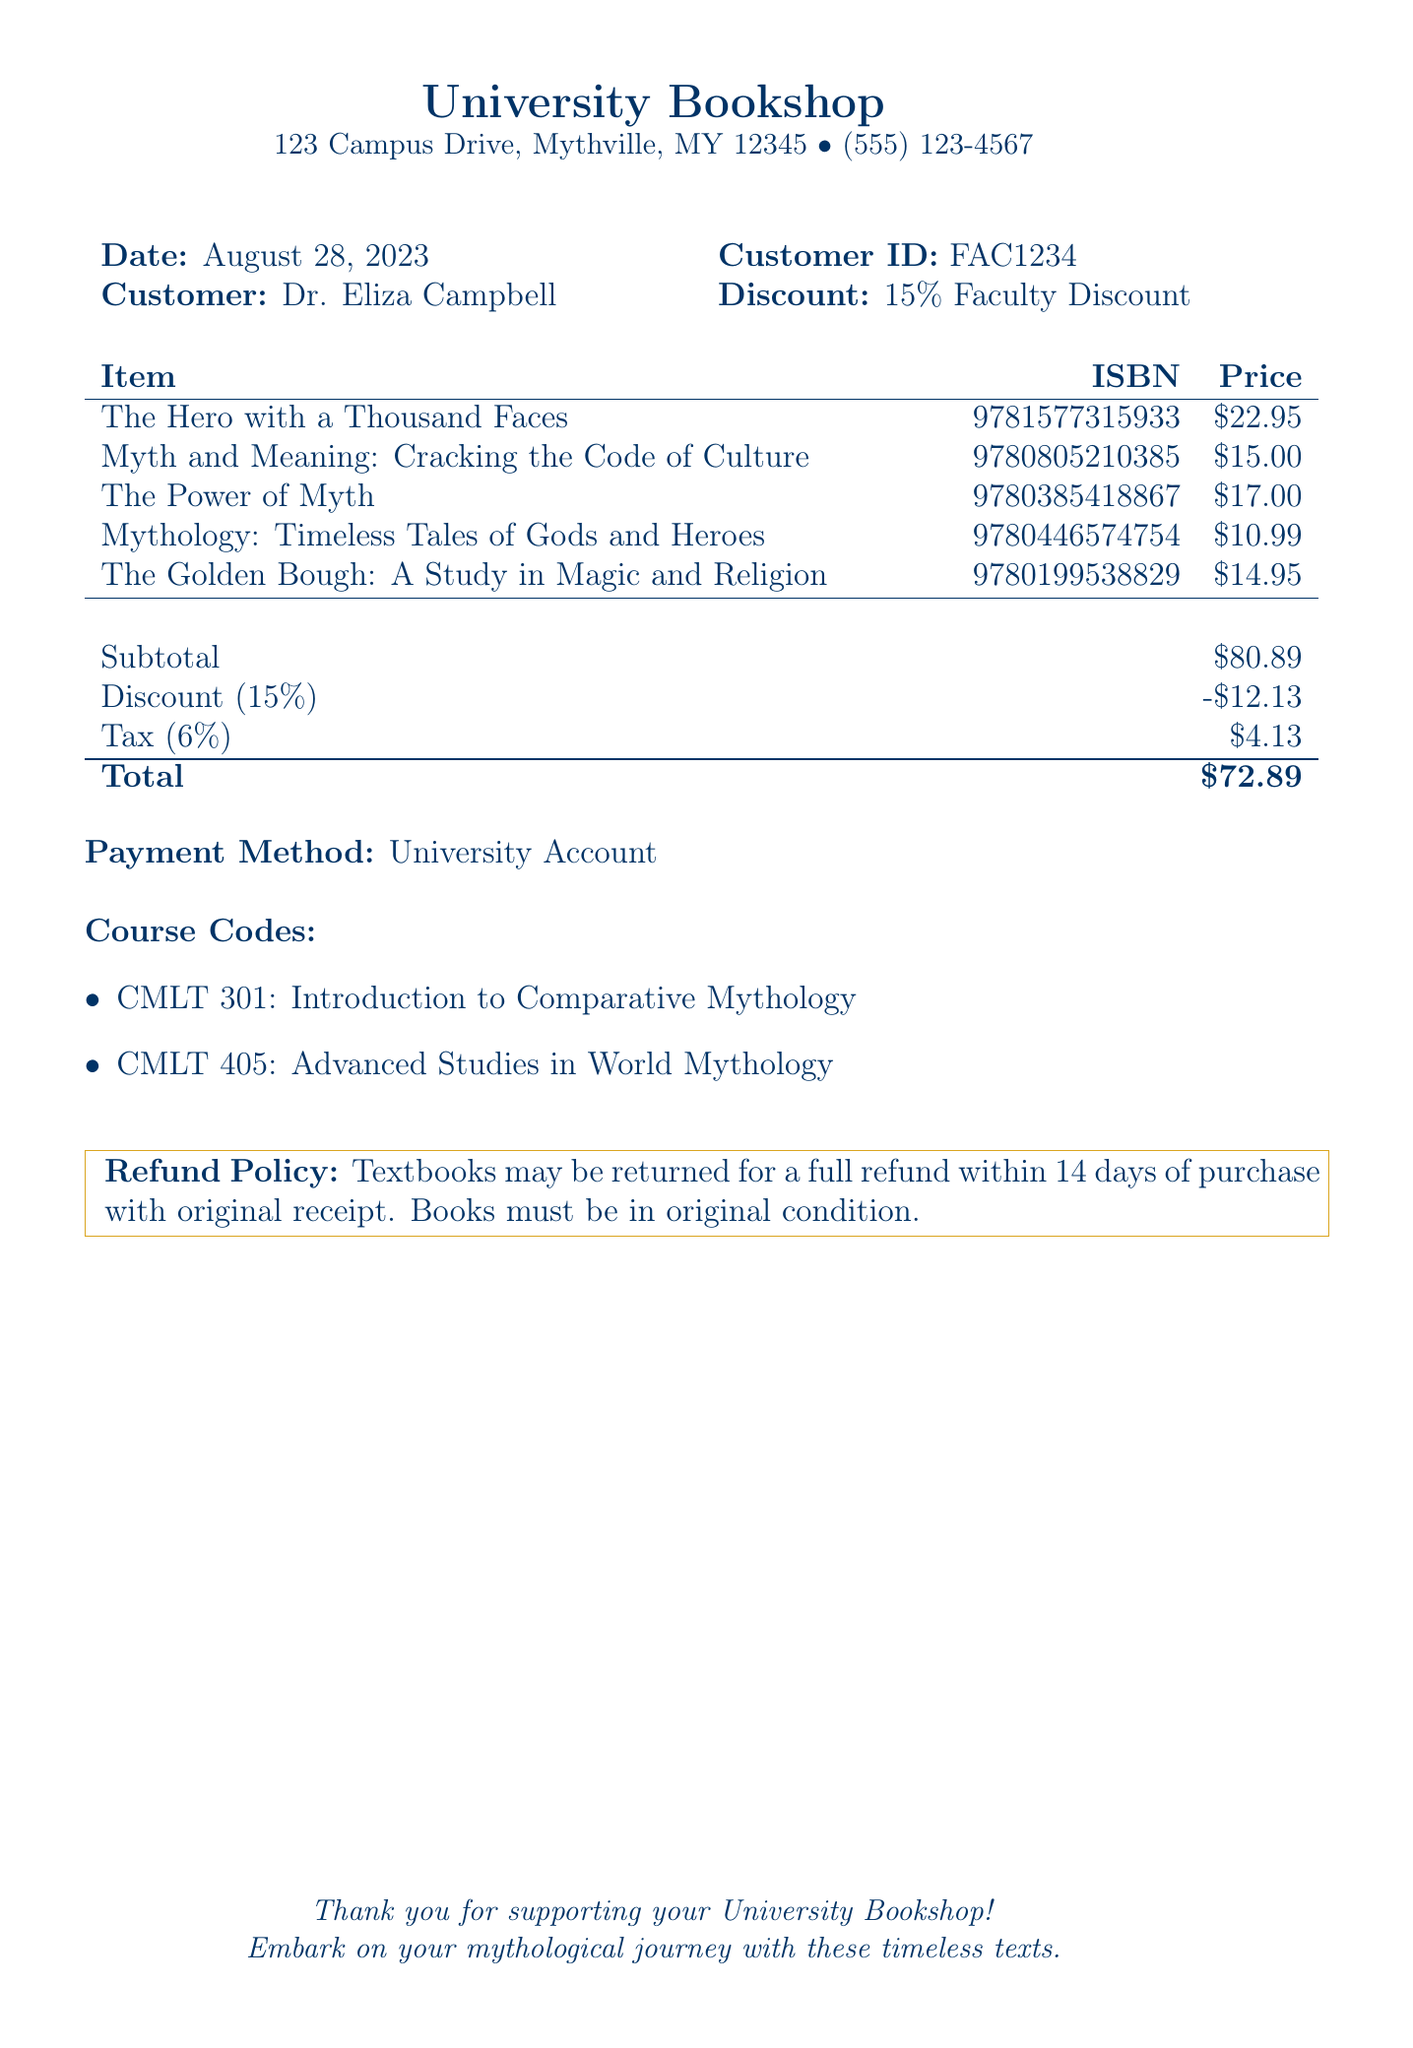What is the date of the receipt? The date listed on the receipt indicates when the purchase was made, which is August 28, 2023.
Answer: August 28, 2023 Who is the customer on this receipt? The receipt specifies the name of the customer, which is Dr. Eliza Campbell.
Answer: Dr. Eliza Campbell What is the ISBN of "The Power of Myth"? The ISBN is a unique identifier for books, and for "The Power of Myth," it is provided as 9780385418867.
Answer: 9780385418867 What is the discount percentage applied? The receipt indicates a discount that is expressed as a percentage off the total price, which is 15%.
Answer: 15% What is the total amount after applying the discount and tax? The total amount listed at the end of the receipt after deductions for discount and tax is the final amount due, which is $72.89.
Answer: $72.89 Which payment method was used? The document states the payment was made through a specific method indicated on the receipt, which is a University Account.
Answer: University Account What is the subtotal before any deductions? The subtotal is the total of all items before any discounts or tax are applied and is mentioned as $80.89.
Answer: $80.89 What is the tax rate applied to the purchase? The tax rate is explicitly stated as a percentage for the total purchase, which is 6%.
Answer: 6% What is the refund policy for the textbooks? The receipt outlines the conditions under which textbooks may be returned, specifically within 14 days with original receipt in original condition.
Answer: 14 days What course codes are associated with this receipt? The document lists course codes relevant to the purchased items, which include CMLT 301 and CMLT 405.
Answer: CMLT 301, CMLT 405 